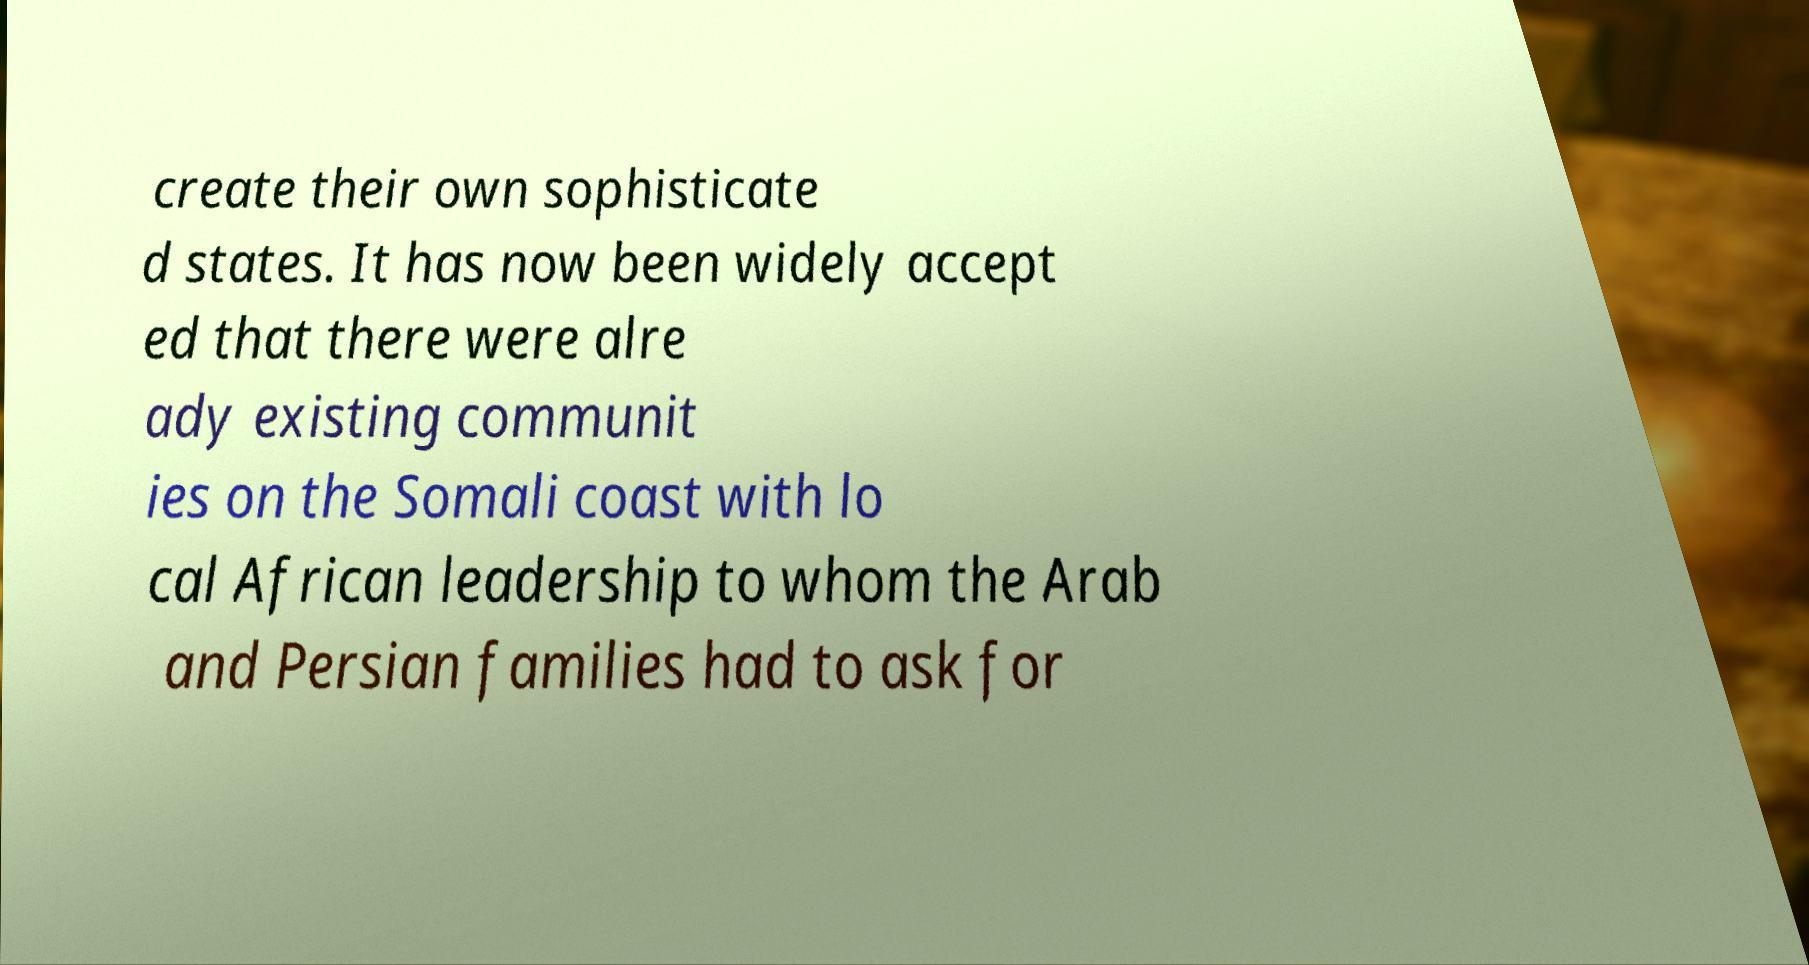Could you assist in decoding the text presented in this image and type it out clearly? create their own sophisticate d states. It has now been widely accept ed that there were alre ady existing communit ies on the Somali coast with lo cal African leadership to whom the Arab and Persian families had to ask for 